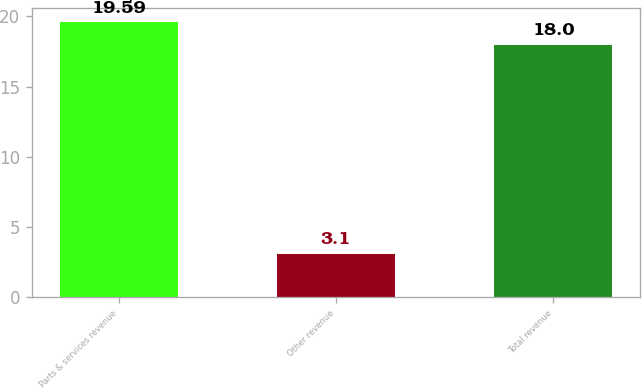<chart> <loc_0><loc_0><loc_500><loc_500><bar_chart><fcel>Parts & services revenue<fcel>Other revenue<fcel>Total revenue<nl><fcel>19.59<fcel>3.1<fcel>18<nl></chart> 